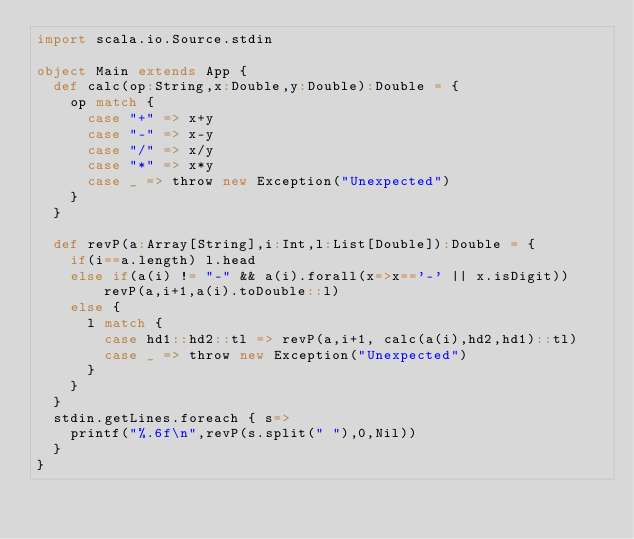<code> <loc_0><loc_0><loc_500><loc_500><_Scala_>import scala.io.Source.stdin

object Main extends App {
  def calc(op:String,x:Double,y:Double):Double = {
    op match {
      case "+" => x+y
      case "-" => x-y
      case "/" => x/y
      case "*" => x*y
      case _ => throw new Exception("Unexpected")
    }
  }

  def revP(a:Array[String],i:Int,l:List[Double]):Double = {
    if(i==a.length) l.head
    else if(a(i) != "-" && a(i).forall(x=>x=='-' || x.isDigit)) revP(a,i+1,a(i).toDouble::l)
    else {
      l match {
        case hd1::hd2::tl => revP(a,i+1, calc(a(i),hd2,hd1)::tl)
        case _ => throw new Exception("Unexpected")
      }
    }
  }
  stdin.getLines.foreach { s=>
    printf("%.6f\n",revP(s.split(" "),0,Nil))
  }
}</code> 